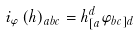Convert formula to latex. <formula><loc_0><loc_0><loc_500><loc_500>i _ { \varphi } \left ( h \right ) _ { a b c } = h _ { [ a } ^ { d } \varphi _ { b c ] d }</formula> 